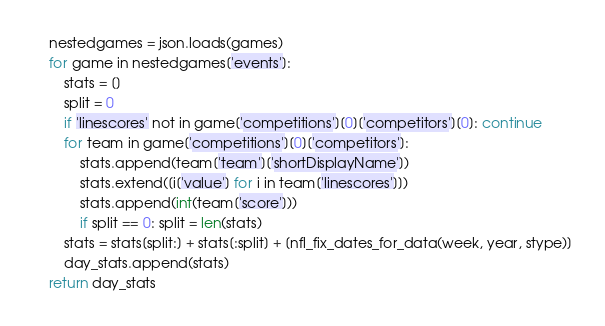Convert code to text. <code><loc_0><loc_0><loc_500><loc_500><_Python_>	nestedgames = json.loads(games)
	for game in nestedgames['events']:
		stats = []
		split = 0
		if 'linescores' not in game['competitions'][0]['competitors'][0]: continue
		for team in game['competitions'][0]['competitors']:
			stats.append(team['team']['shortDisplayName'])
			stats.extend([i['value'] for i in team['linescores']])
			stats.append(int(team['score']))
			if split == 0: split = len(stats)
		stats = stats[split:] + stats[:split] + [nfl_fix_dates_for_data(week, year, stype)]
		day_stats.append(stats)
	return day_stats</code> 